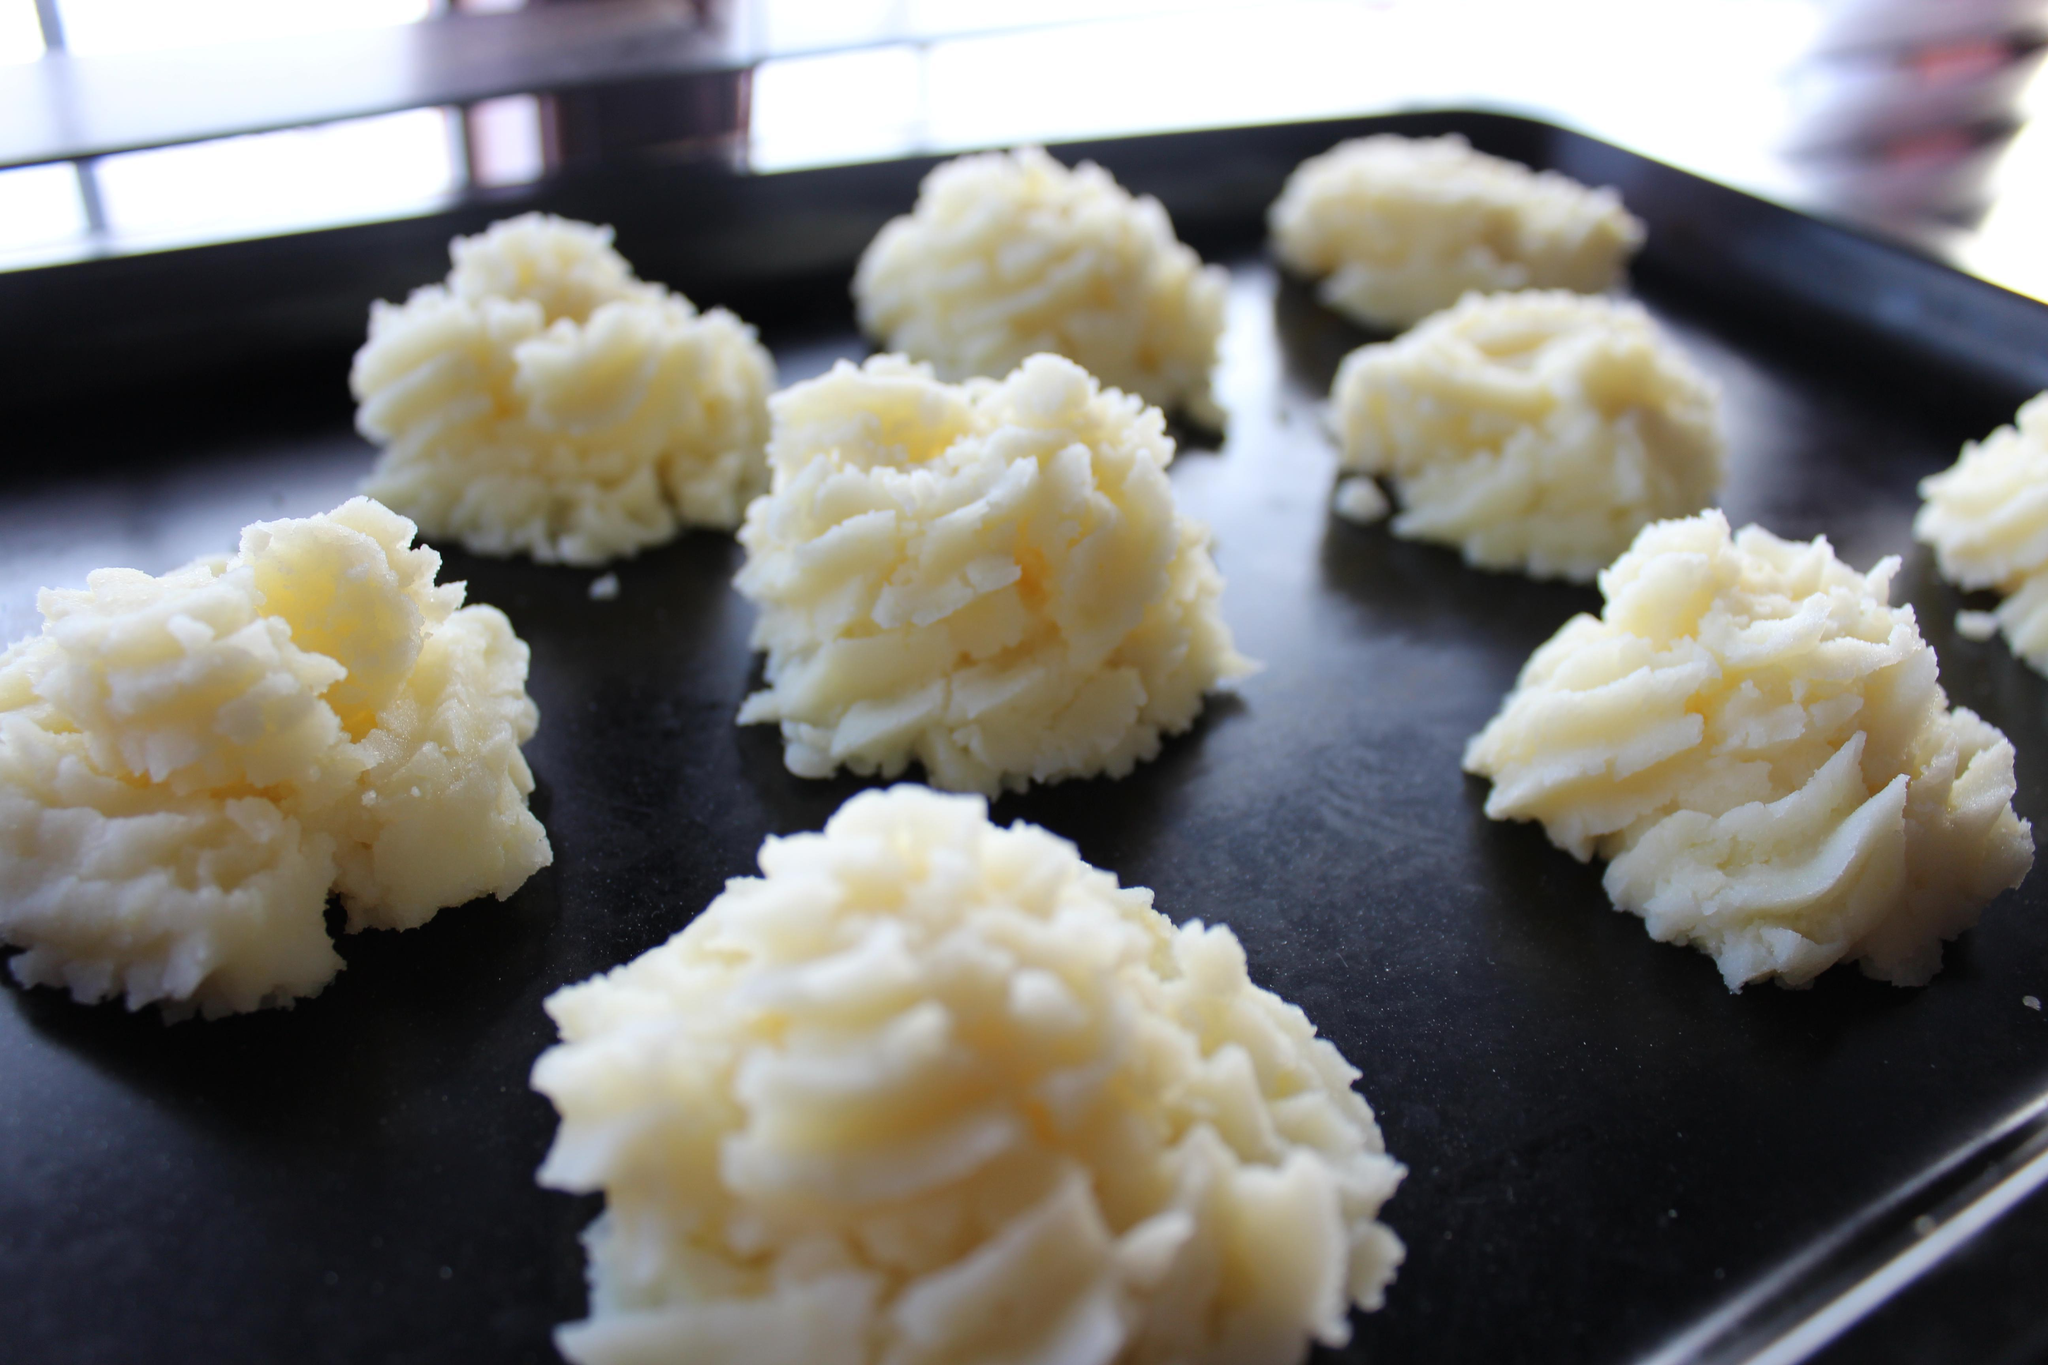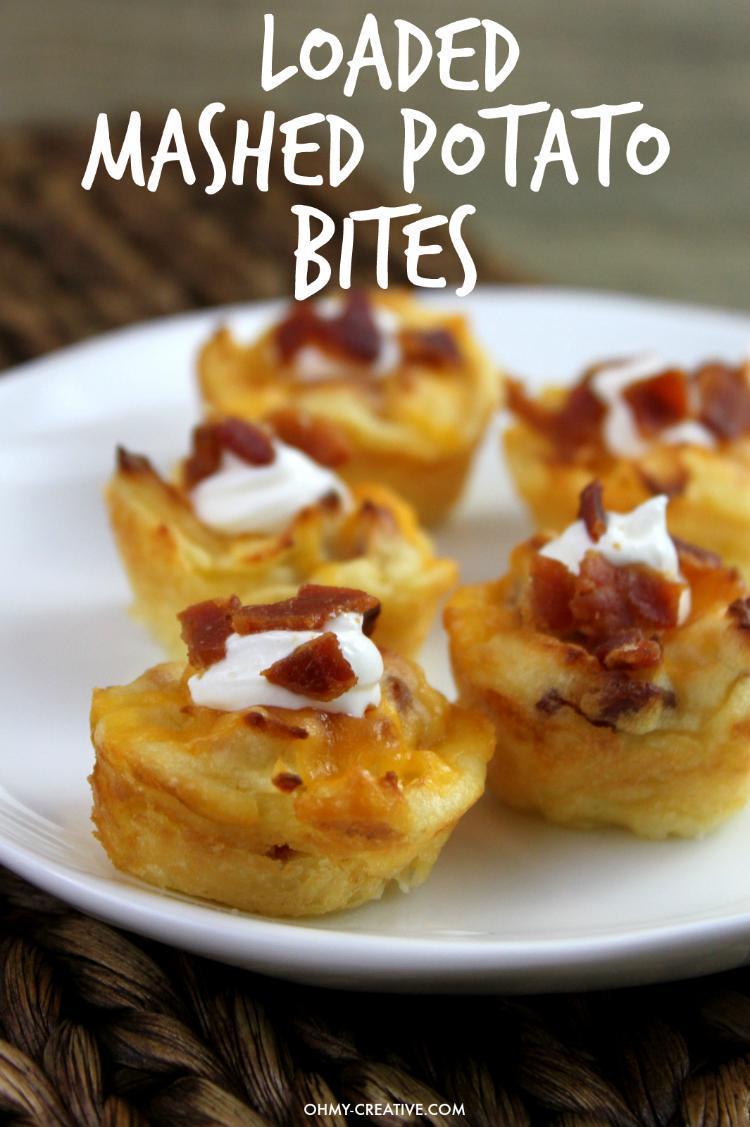The first image is the image on the left, the second image is the image on the right. Considering the images on both sides, is "Mashed potatoes in each image are served in round white dishes with flecks of garnish." valid? Answer yes or no. No. The first image is the image on the left, the second image is the image on the right. Analyze the images presented: Is the assertion "A fork sits near a plate of food in one of the images." valid? Answer yes or no. No. 